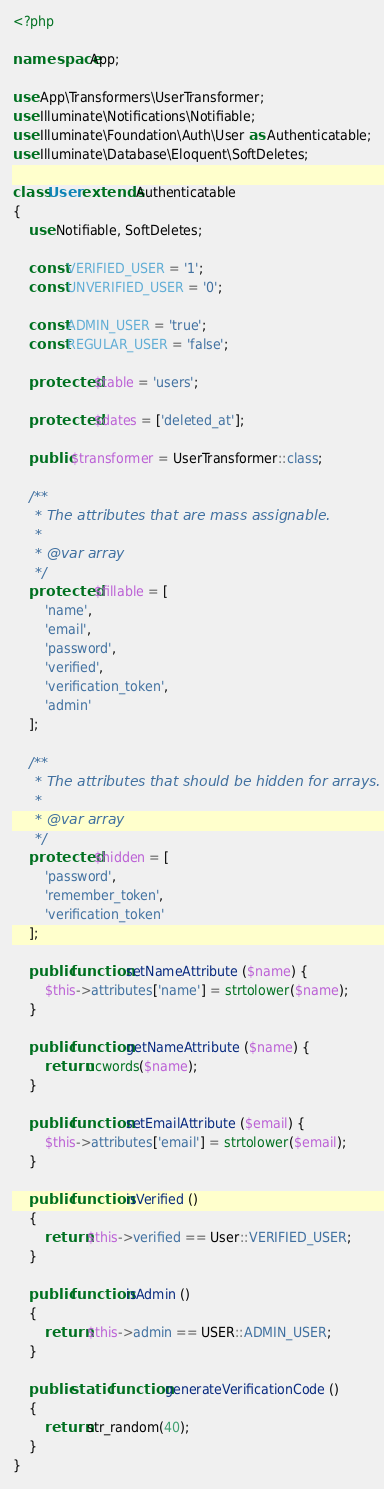Convert code to text. <code><loc_0><loc_0><loc_500><loc_500><_PHP_><?php

namespace App;

use App\Transformers\UserTransformer;
use Illuminate\Notifications\Notifiable;
use Illuminate\Foundation\Auth\User as Authenticatable;
use Illuminate\Database\Eloquent\SoftDeletes;

class User extends Authenticatable
{
    use Notifiable, SoftDeletes;

    const VERIFIED_USER = '1';
    const UNVERIFIED_USER = '0';

    const ADMIN_USER = 'true';
    const REGULAR_USER = 'false';

    protected $table = 'users';

    protected $dates = ['deleted_at'];

    public $transformer = UserTransformer::class;

    /**
     * The attributes that are mass assignable.
     *
     * @var array
     */
    protected $fillable = [
        'name', 
        'email', 
        'password',
        'verified',
        'verification_token',
        'admin'
    ];

    /**
     * The attributes that should be hidden for arrays.
     *
     * @var array
     */
    protected $hidden = [
        'password', 
        'remember_token',
        'verification_token'
    ];

    public function setNameAttribute ($name) {
        $this->attributes['name'] = strtolower($name);
    }

    public function getNameAttribute ($name) {
        return ucwords($name);
    }

    public function setEmailAttribute ($email) {
        $this->attributes['email'] = strtolower($email);
    }

    public function isVerified () 
    {
        return $this->verified == User::VERIFIED_USER;
    }

    public function isAdmin () 
    {
        return $this->admin == USER::ADMIN_USER;
    }

    public static function generateVerificationCode ()
    {
        return str_random(40);
    }
}
</code> 